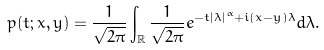Convert formula to latex. <formula><loc_0><loc_0><loc_500><loc_500>p ( t ; x , y ) = \frac { 1 } { \sqrt { 2 \pi } } \int _ { \mathbb { R } } \frac { 1 } { \sqrt { 2 \pi } } e ^ { - t | \lambda | ^ { \alpha } + i ( x - y ) \lambda } d \lambda .</formula> 